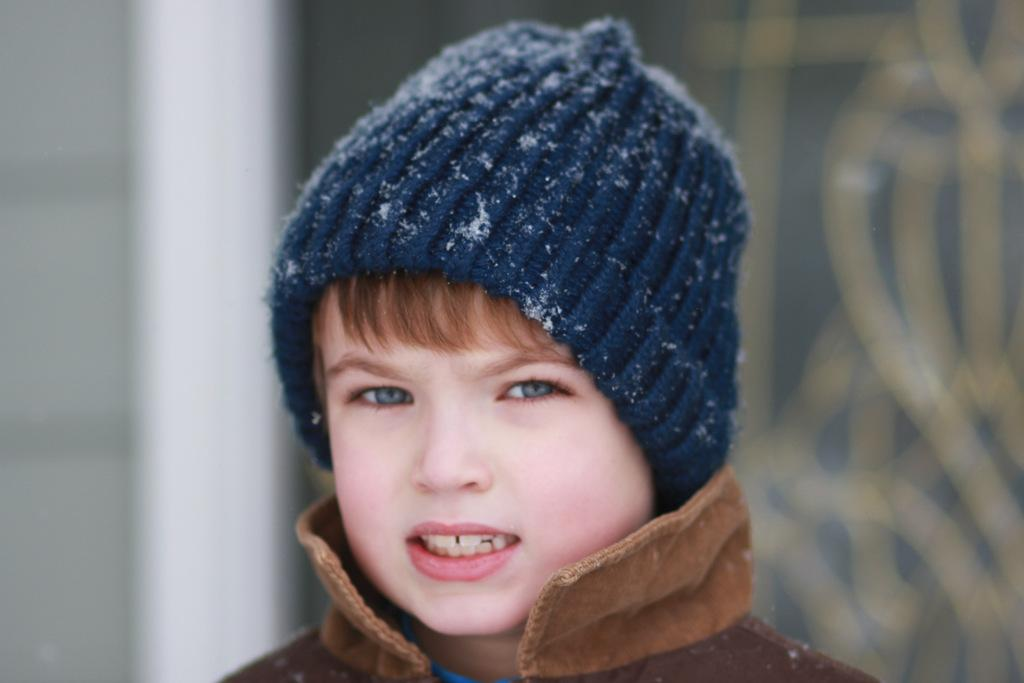What is the main subject of the image? The main subject of the image is a kid. What is the kid wearing in the image? The kid is wearing a jacket and a head cap. Can you describe the head cap in more detail? The head cap has snow particles on it. What color is the crayon the kid is holding in the image? There is no crayon present in the image. What historical event is depicted in the image? The image does not depict any historical event; it features a kid wearing a jacket and head cap with snow particles. 